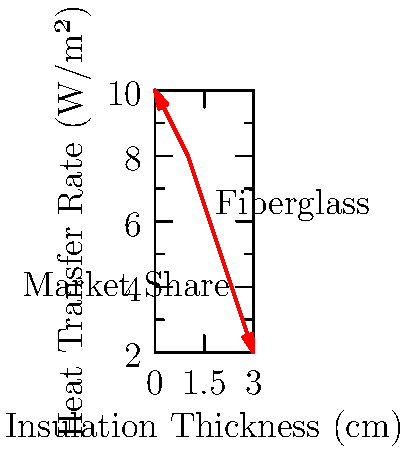As a representative of a multinational insulation company, you're analyzing heat transfer rates through different materials. The graph shows the relationship between insulation thickness and heat transfer rate for a new fiberglass product. If a competitor's product achieves a heat transfer rate of 4 W/m² at 2.5 cm thickness, what percentage thicker must your fiberglass insulation be to match this performance? To solve this problem, we need to follow these steps:

1. Determine the heat transfer rate for the competitor's product:
   4 W/m² at 2.5 cm thickness

2. Find the thickness of our fiberglass insulation that achieves the same heat transfer rate:
   From the graph, we can estimate that 4 W/m² corresponds to about 2.75 cm thickness for our fiberglass insulation.

3. Calculate the percentage difference in thickness:
   Let $x$ be the percentage increase in thickness.
   
   $$x = \frac{\text{Our thickness} - \text{Competitor thickness}}{\text{Competitor thickness}} \times 100\%$$
   
   $$x = \frac{2.75 \text{ cm} - 2.5 \text{ cm}}{2.5 \text{ cm}} \times 100\%$$
   
   $$x = \frac{0.25 \text{ cm}}{2.5 \text{ cm}} \times 100\% = 0.1 \times 100\% = 10\%$$

Therefore, our fiberglass insulation must be 10% thicker to match the competitor's performance.
Answer: 10% 